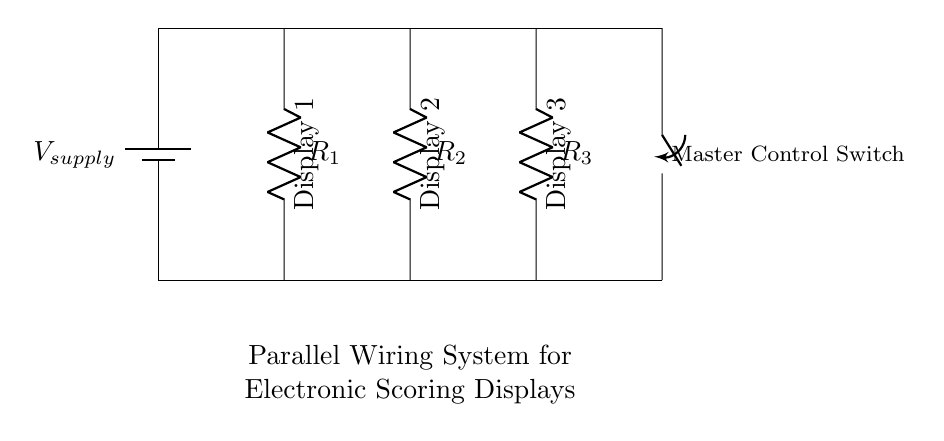What are the components in this circuit? The components visible in the circuit diagram include a battery, three resistors, and a switch. By examining each part, the battery represents the voltage supply, while the resistors are labeled R1, R2, and R3, indicating their roles in the circuit. Finally, the switch is shown at the end, serving as a master control for the display.
Answer: battery, resistors, switch What is the purpose of the master control switch? The master control switch allows the user to turn the entire circuit on or off, effectively controlling the flow of current to all connected displays. Inspecting the diagram, it is situated at the end of the circuit, indicating it controls the power to the parallel setup of displays.
Answer: on/off control How many displays are connected in this circuit? There are three displays connected in this circuit as indicated by the labels next to resistors R1, R2, and R3. Each display corresponds to a resistor, showcasing that each is receiving power from the parallel configuration.
Answer: three What is the total resistance if all resistors are the same value? In parallel circuits, the total resistance can be calculated using the formula one over the sum of the reciprocals of individual resistances. If all resistors have the same value, for example R, the total resistance would be R divided by the number of resistors: thus, it is R divided by three for three resistors.
Answer: R/3 What happens to the voltage across each display? In a parallel circuit, the voltage across each component remains equal to the supply voltage. This can be deduced from the diagram, where the voltage source applies the same potential difference across all parallel branches.
Answer: equal to supply voltage Why is this circuit configuration beneficial for electronic scoring displays? This parallel circuit configuration is beneficial because it ensures that each display operates independently. Therefore, if one display fails, the others continue to work, maintaining functionality, as seen from the circuit where displays are connected in parallel rather than series.
Answer: independence of displays 